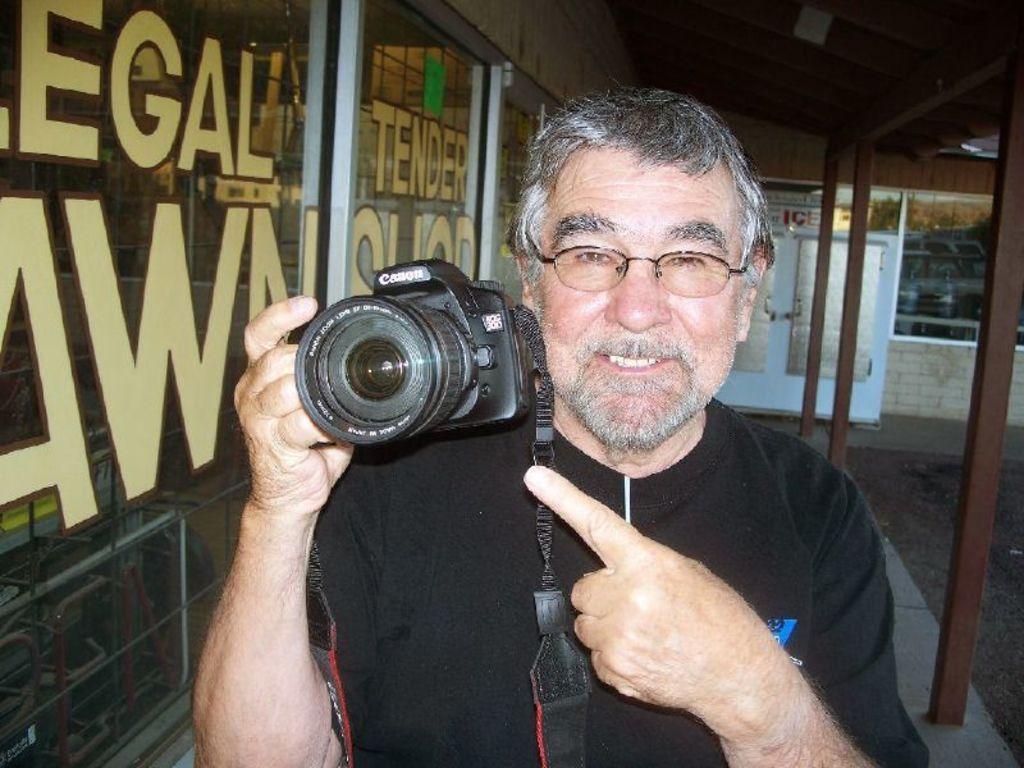Please provide a concise description of this image. The man in black t-shirt is holding a camera. In a glass there is a reflection of a vehicle's. 